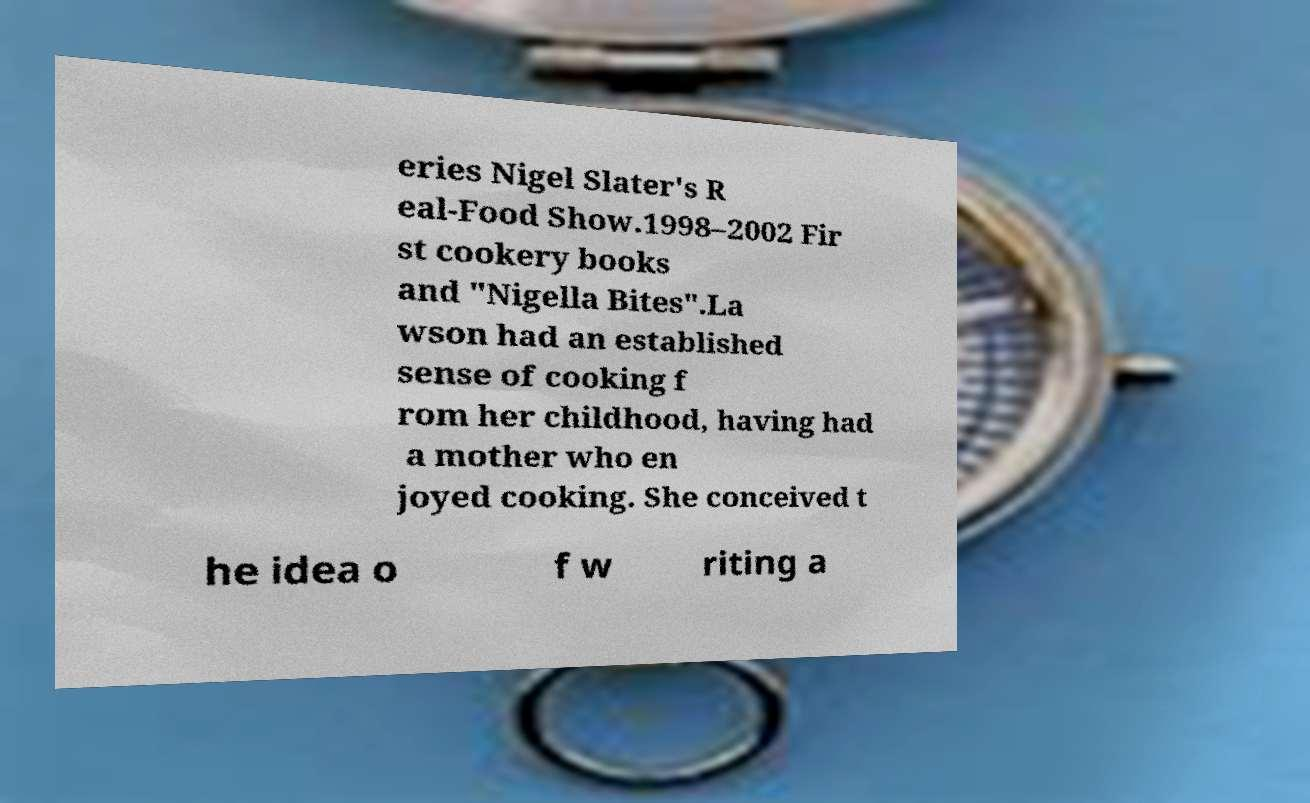Please read and relay the text visible in this image. What does it say? eries Nigel Slater's R eal-Food Show.1998–2002 Fir st cookery books and "Nigella Bites".La wson had an established sense of cooking f rom her childhood, having had a mother who en joyed cooking. She conceived t he idea o f w riting a 